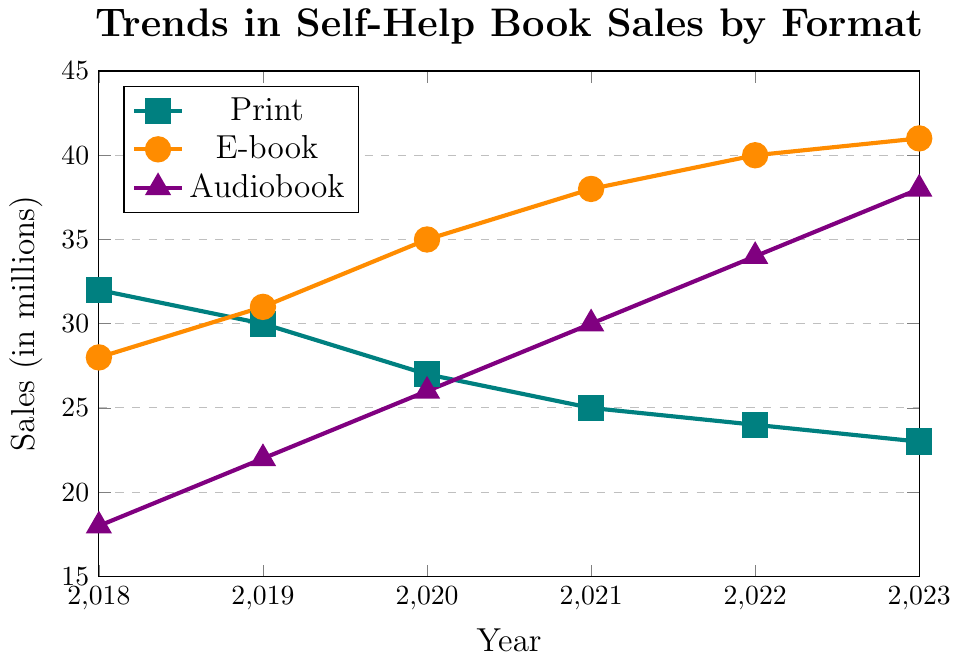Which format had the highest sales in 2023? The figure shows three lines representing print, e-book, and audiobook sales. The highest point for 2023 is on the e-book line.
Answer: E-book How did print book sales change from 2018 to 2023? To determine the change, subtract the 2023 value from the 2018 value: 32 (2018) - 23 (2023).
Answer: Decreased by 9 million What's the combined total of e-book and audiobook sales in 2020? Find the values for e-book (35) and audiobook (26) in 2020, then add them: 35 + 26.
Answer: 61 million Which year had the highest total sales for all three formats combined? Calculate the sum of sales for all three formats for each year and find the year with the highest total. 2018: 32+28+18=78, 2019:30+31+22=83, 2020:27+35+26=88, 2021:25+38+30=93, 2022:24+40+34=98, 2023:23+41+38=102.
Answer: 2023 When did audiobook sales surpass print book sales? Look for the first year where the audiobook line is higher than the print book line. This happens after 2020.
Answer: 2021 What is the trend for e-book sales from 2018 to 2023? Observe the e-book line from 2018 to 2023. The line consistently moves upward each year.
Answer: Increased By how much did audiobook sales increase from 2018 to 2023? Subtract the 2018 value from the 2023 value: 38 (2023) - 18 (2018).
Answer: Increased by 20 million Are print book sales higher, lower, or equal to e-book sales in 2021? Compare the values for print (25) and e-book (38) in 2021.
Answer: Lower Which format showed the most significant growth between 2018 and 2023? Compare the increase in values from 2018 to 2023 for all three formats. E-books increased from 28 to 41, audiobooks from 18 to 38, and print books decreased.
Answer: Audiobook What is the average sales figure for print books over the six years? Add the values for each year: 32+30+27+25+24+23=161, then divide by the number of years (6): 161/6.
Answer: 26.83 million 